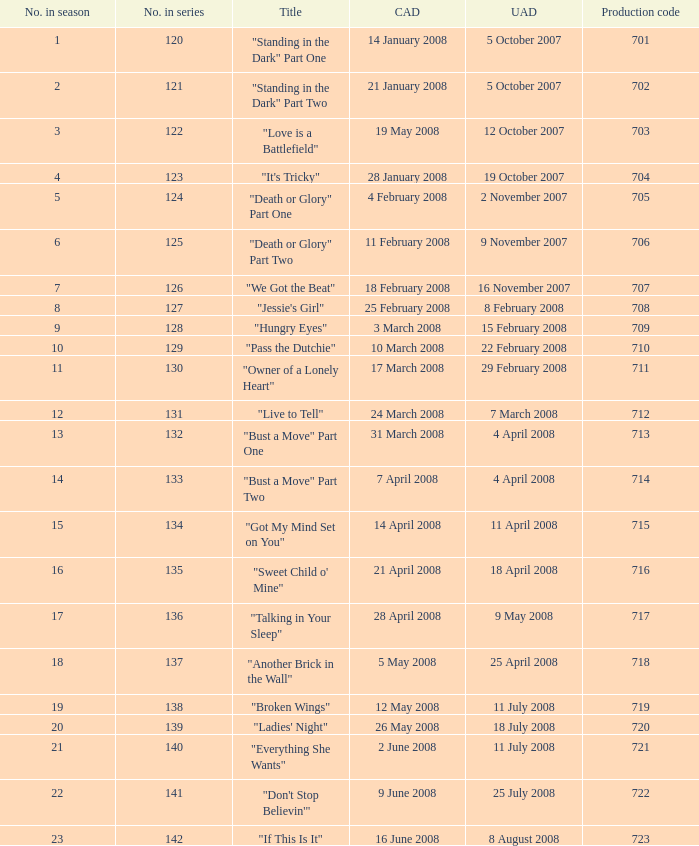The U.S. airdate of 4 april 2008 had a production code of what? 714.0. Parse the full table. {'header': ['No. in season', 'No. in series', 'Title', 'CAD', 'UAD', 'Production code'], 'rows': [['1', '120', '"Standing in the Dark" Part One', '14 January 2008', '5 October 2007', '701'], ['2', '121', '"Standing in the Dark" Part Two', '21 January 2008', '5 October 2007', '702'], ['3', '122', '"Love is a Battlefield"', '19 May 2008', '12 October 2007', '703'], ['4', '123', '"It\'s Tricky"', '28 January 2008', '19 October 2007', '704'], ['5', '124', '"Death or Glory" Part One', '4 February 2008', '2 November 2007', '705'], ['6', '125', '"Death or Glory" Part Two', '11 February 2008', '9 November 2007', '706'], ['7', '126', '"We Got the Beat"', '18 February 2008', '16 November 2007', '707'], ['8', '127', '"Jessie\'s Girl"', '25 February 2008', '8 February 2008', '708'], ['9', '128', '"Hungry Eyes"', '3 March 2008', '15 February 2008', '709'], ['10', '129', '"Pass the Dutchie"', '10 March 2008', '22 February 2008', '710'], ['11', '130', '"Owner of a Lonely Heart"', '17 March 2008', '29 February 2008', '711'], ['12', '131', '"Live to Tell"', '24 March 2008', '7 March 2008', '712'], ['13', '132', '"Bust a Move" Part One', '31 March 2008', '4 April 2008', '713'], ['14', '133', '"Bust a Move" Part Two', '7 April 2008', '4 April 2008', '714'], ['15', '134', '"Got My Mind Set on You"', '14 April 2008', '11 April 2008', '715'], ['16', '135', '"Sweet Child o\' Mine"', '21 April 2008', '18 April 2008', '716'], ['17', '136', '"Talking in Your Sleep"', '28 April 2008', '9 May 2008', '717'], ['18', '137', '"Another Brick in the Wall"', '5 May 2008', '25 April 2008', '718'], ['19', '138', '"Broken Wings"', '12 May 2008', '11 July 2008', '719'], ['20', '139', '"Ladies\' Night"', '26 May 2008', '18 July 2008', '720'], ['21', '140', '"Everything She Wants"', '2 June 2008', '11 July 2008', '721'], ['22', '141', '"Don\'t Stop Believin\'"', '9 June 2008', '25 July 2008', '722'], ['23', '142', '"If This Is It"', '16 June 2008', '8 August 2008', '723']]} 